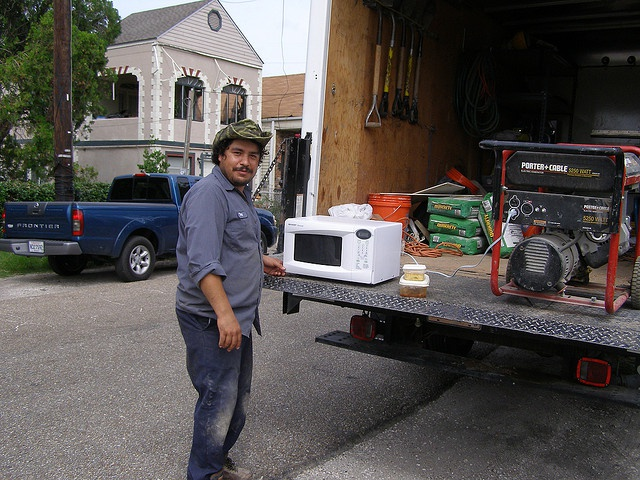Describe the objects in this image and their specific colors. I can see truck in black, gray, lavender, and maroon tones, people in black and gray tones, truck in black, navy, and gray tones, and microwave in black, lavender, and darkgray tones in this image. 